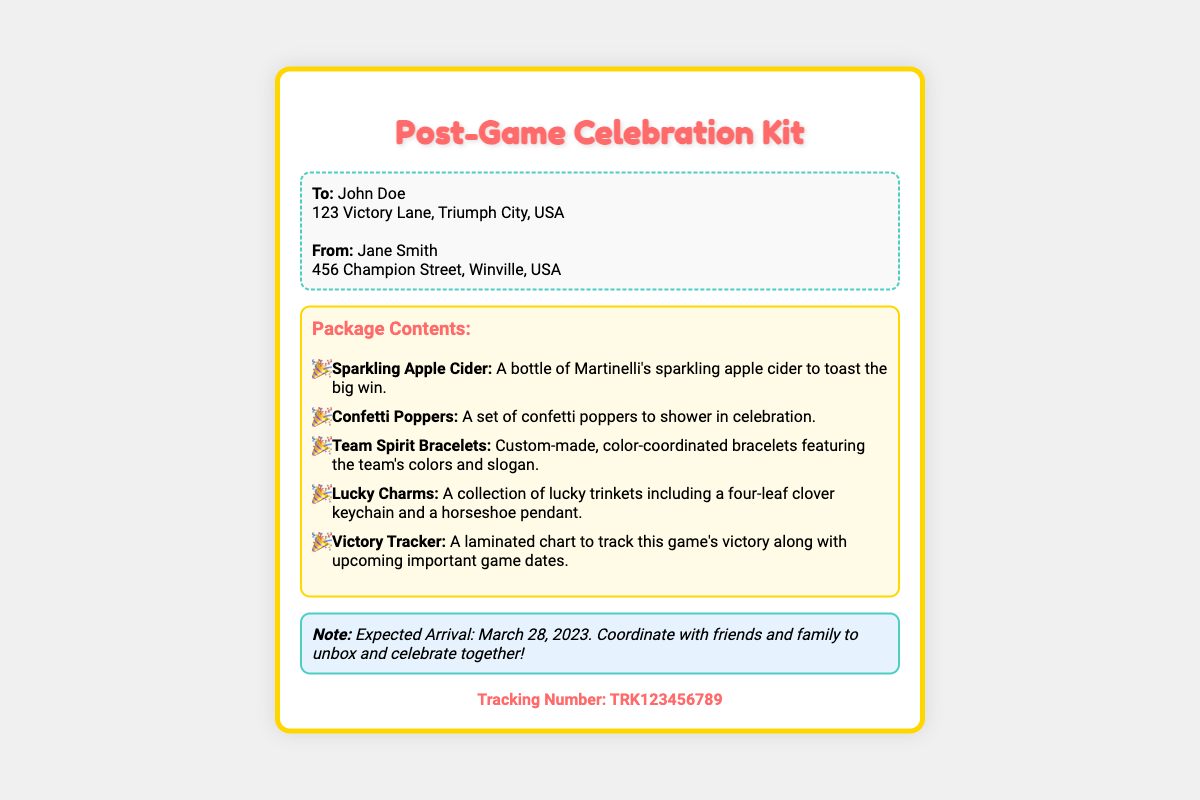What is the title of the package? The title of the package is prominently displayed at the top of the document.
Answer: Post-Game Celebration Kit Who is the recipient of the package? The recipient's name is listed in the address section at the beginning of the document.
Answer: John Doe What item is included for toasting? The contents list specifies an item meant for toasting in the celebration.
Answer: Sparkling Apple Cider How many lucky trinkets are mentioned? The document lists specific lucky trinkets included in the package.
Answer: Two What is the expected arrival date of the package? The expected arrival date is noted in the document as part of the celebratory message.
Answer: March 28, 2023 What tracking number is provided? The tracking number is mentioned at the bottom of the document for shipment tracking purposes.
Answer: TRK123456789 What type of chart is included in the kit? The contents section mentions a specific type of chart that tracks victories and game dates.
Answer: Victory Tracker What additional item helps celebrate? The document lists a celebratory item meant to enhance the celebration atmosphere.
Answer: Confetti Poppers 